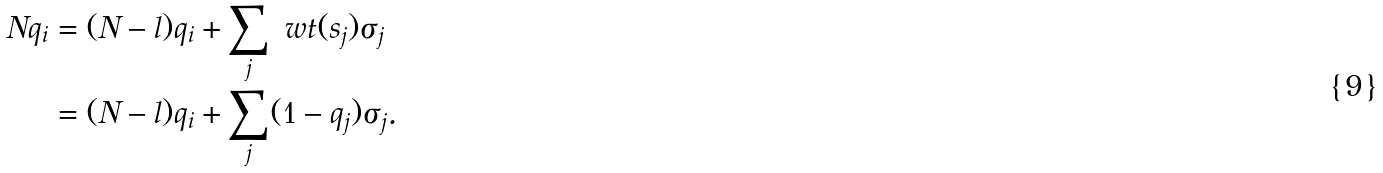<formula> <loc_0><loc_0><loc_500><loc_500>N q _ { i } & = ( N - l ) q _ { i } + \sum _ { j } \ w t ( s _ { j } ) \sigma _ { j } \\ & = ( N - l ) q _ { i } + \sum _ { j } ( 1 - q _ { j } ) \sigma _ { j } . \\</formula> 